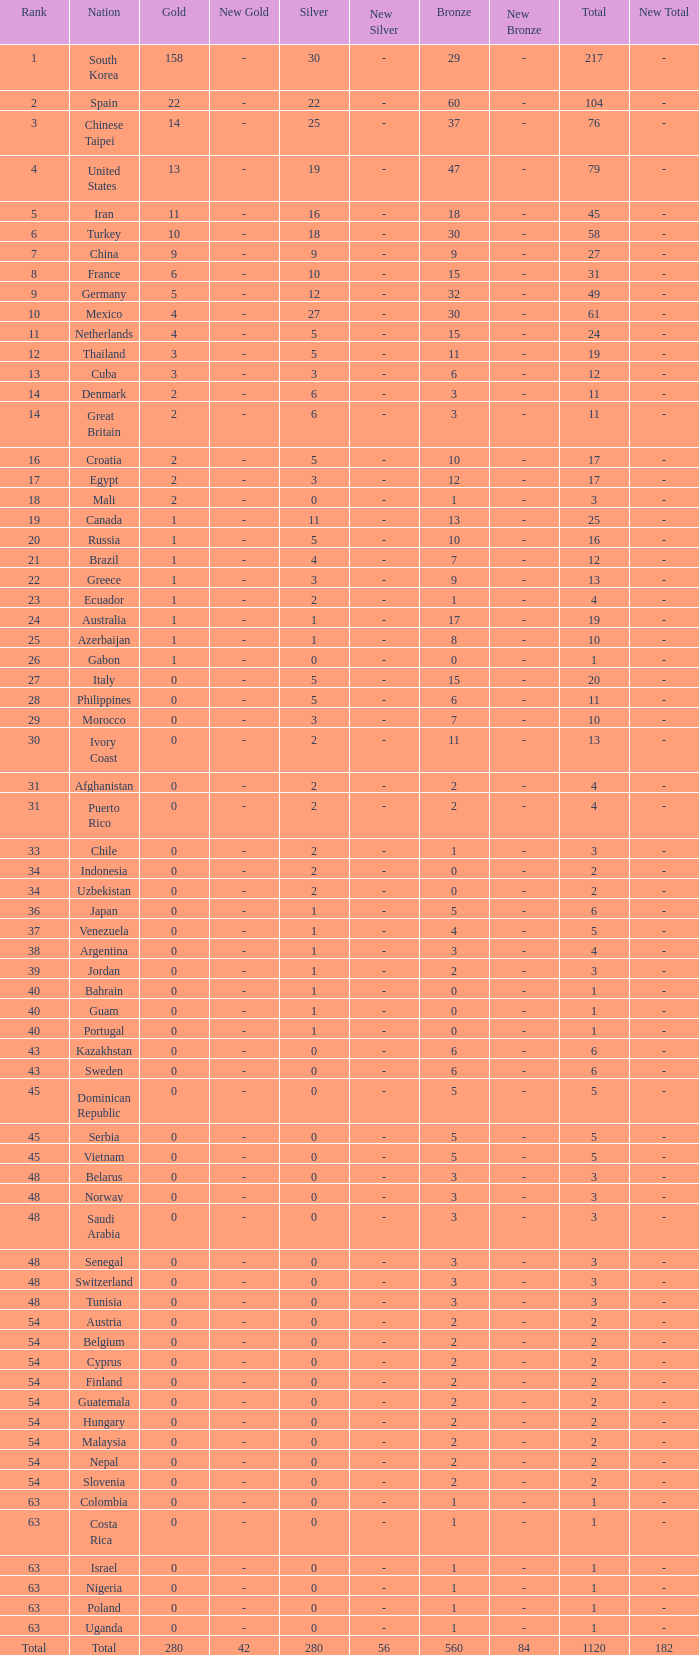What is the Total medals for the Nation ranking 33 with more than 1 Bronze? None. 